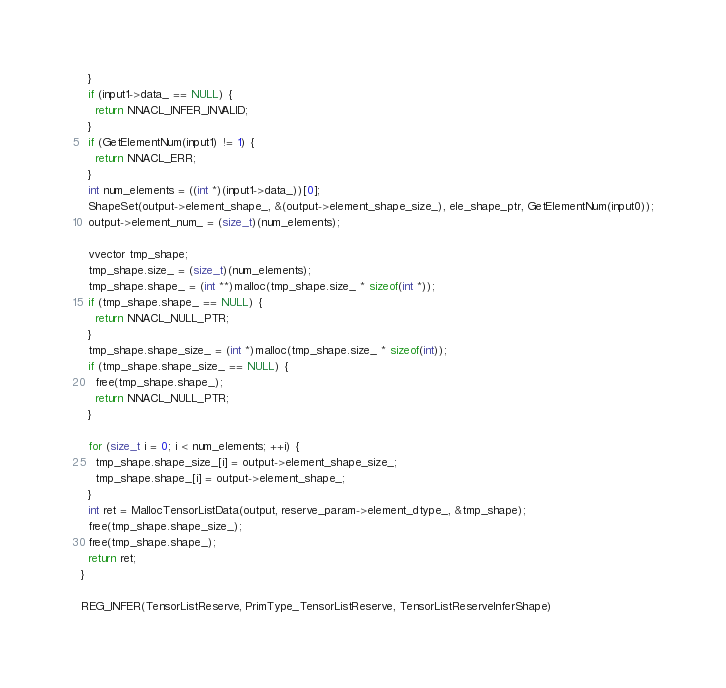Convert code to text. <code><loc_0><loc_0><loc_500><loc_500><_C_>  }
  if (input1->data_ == NULL) {
    return NNACL_INFER_INVALID;
  }
  if (GetElementNum(input1) != 1) {
    return NNACL_ERR;
  }
  int num_elements = ((int *)(input1->data_))[0];
  ShapeSet(output->element_shape_, &(output->element_shape_size_), ele_shape_ptr, GetElementNum(input0));
  output->element_num_ = (size_t)(num_elements);

  vvector tmp_shape;
  tmp_shape.size_ = (size_t)(num_elements);
  tmp_shape.shape_ = (int **)malloc(tmp_shape.size_ * sizeof(int *));
  if (tmp_shape.shape_ == NULL) {
    return NNACL_NULL_PTR;
  }
  tmp_shape.shape_size_ = (int *)malloc(tmp_shape.size_ * sizeof(int));
  if (tmp_shape.shape_size_ == NULL) {
    free(tmp_shape.shape_);
    return NNACL_NULL_PTR;
  }

  for (size_t i = 0; i < num_elements; ++i) {
    tmp_shape.shape_size_[i] = output->element_shape_size_;
    tmp_shape.shape_[i] = output->element_shape_;
  }
  int ret = MallocTensorListData(output, reserve_param->element_dtype_, &tmp_shape);
  free(tmp_shape.shape_size_);
  free(tmp_shape.shape_);
  return ret;
}

REG_INFER(TensorListReserve, PrimType_TensorListReserve, TensorListReserveInferShape)
</code> 